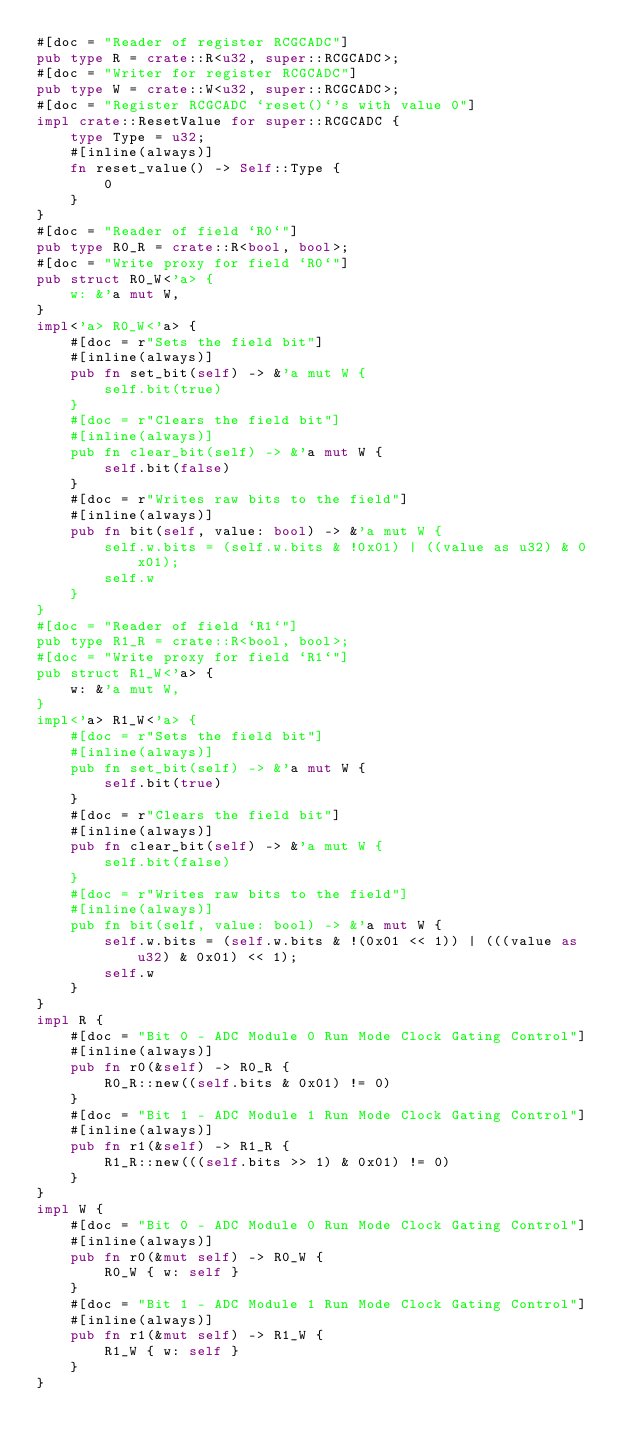<code> <loc_0><loc_0><loc_500><loc_500><_Rust_>#[doc = "Reader of register RCGCADC"]
pub type R = crate::R<u32, super::RCGCADC>;
#[doc = "Writer for register RCGCADC"]
pub type W = crate::W<u32, super::RCGCADC>;
#[doc = "Register RCGCADC `reset()`'s with value 0"]
impl crate::ResetValue for super::RCGCADC {
    type Type = u32;
    #[inline(always)]
    fn reset_value() -> Self::Type {
        0
    }
}
#[doc = "Reader of field `R0`"]
pub type R0_R = crate::R<bool, bool>;
#[doc = "Write proxy for field `R0`"]
pub struct R0_W<'a> {
    w: &'a mut W,
}
impl<'a> R0_W<'a> {
    #[doc = r"Sets the field bit"]
    #[inline(always)]
    pub fn set_bit(self) -> &'a mut W {
        self.bit(true)
    }
    #[doc = r"Clears the field bit"]
    #[inline(always)]
    pub fn clear_bit(self) -> &'a mut W {
        self.bit(false)
    }
    #[doc = r"Writes raw bits to the field"]
    #[inline(always)]
    pub fn bit(self, value: bool) -> &'a mut W {
        self.w.bits = (self.w.bits & !0x01) | ((value as u32) & 0x01);
        self.w
    }
}
#[doc = "Reader of field `R1`"]
pub type R1_R = crate::R<bool, bool>;
#[doc = "Write proxy for field `R1`"]
pub struct R1_W<'a> {
    w: &'a mut W,
}
impl<'a> R1_W<'a> {
    #[doc = r"Sets the field bit"]
    #[inline(always)]
    pub fn set_bit(self) -> &'a mut W {
        self.bit(true)
    }
    #[doc = r"Clears the field bit"]
    #[inline(always)]
    pub fn clear_bit(self) -> &'a mut W {
        self.bit(false)
    }
    #[doc = r"Writes raw bits to the field"]
    #[inline(always)]
    pub fn bit(self, value: bool) -> &'a mut W {
        self.w.bits = (self.w.bits & !(0x01 << 1)) | (((value as u32) & 0x01) << 1);
        self.w
    }
}
impl R {
    #[doc = "Bit 0 - ADC Module 0 Run Mode Clock Gating Control"]
    #[inline(always)]
    pub fn r0(&self) -> R0_R {
        R0_R::new((self.bits & 0x01) != 0)
    }
    #[doc = "Bit 1 - ADC Module 1 Run Mode Clock Gating Control"]
    #[inline(always)]
    pub fn r1(&self) -> R1_R {
        R1_R::new(((self.bits >> 1) & 0x01) != 0)
    }
}
impl W {
    #[doc = "Bit 0 - ADC Module 0 Run Mode Clock Gating Control"]
    #[inline(always)]
    pub fn r0(&mut self) -> R0_W {
        R0_W { w: self }
    }
    #[doc = "Bit 1 - ADC Module 1 Run Mode Clock Gating Control"]
    #[inline(always)]
    pub fn r1(&mut self) -> R1_W {
        R1_W { w: self }
    }
}
</code> 